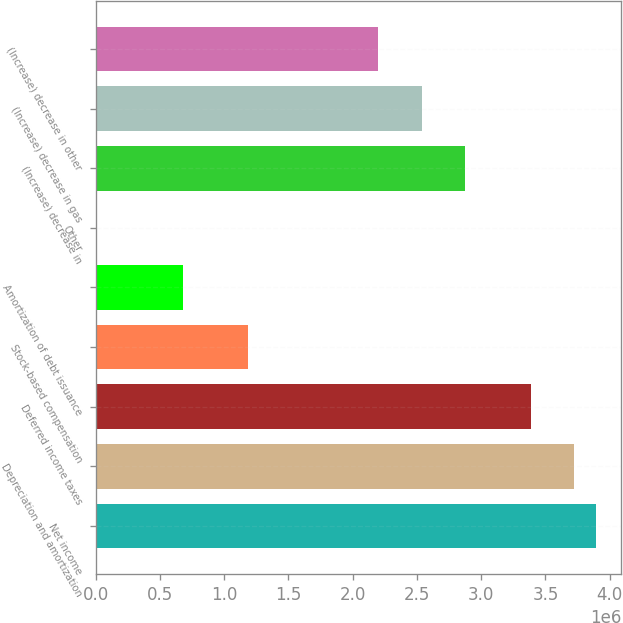<chart> <loc_0><loc_0><loc_500><loc_500><bar_chart><fcel>Net income<fcel>Depreciation and amortization<fcel>Deferred income taxes<fcel>Stock-based compensation<fcel>Amortization of debt issuance<fcel>Other<fcel>(Increase) decrease in<fcel>(Increase) decrease in gas<fcel>(Increase) decrease in other<nl><fcel>3.89348e+06<fcel>3.72425e+06<fcel>3.38578e+06<fcel>1.18578e+06<fcel>678092<fcel>1169<fcel>2.87809e+06<fcel>2.53963e+06<fcel>2.20117e+06<nl></chart> 